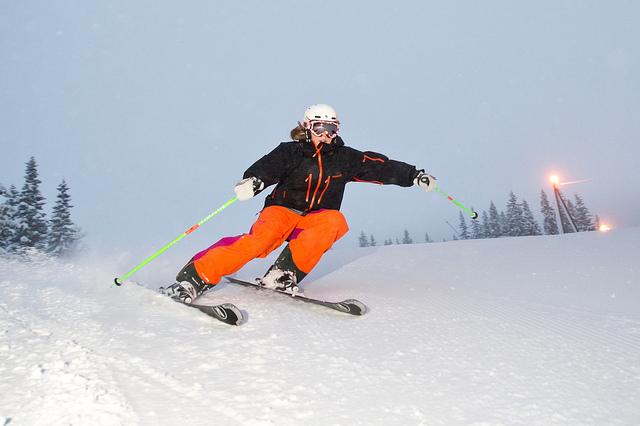Why is the person holding to sticks in his hands?
Keep it brief. Balance. What gender is the person with the white helmet?
Give a very brief answer. Female. Does he have on safety gear?
Concise answer only. Yes. What color is the person's helmet?
Answer briefly. White. What is this person doing in the snow?
Give a very brief answer. Skiing. What game is the person playing?
Keep it brief. Skiing. Is the skier wearing goggles?
Write a very short answer. Yes. 